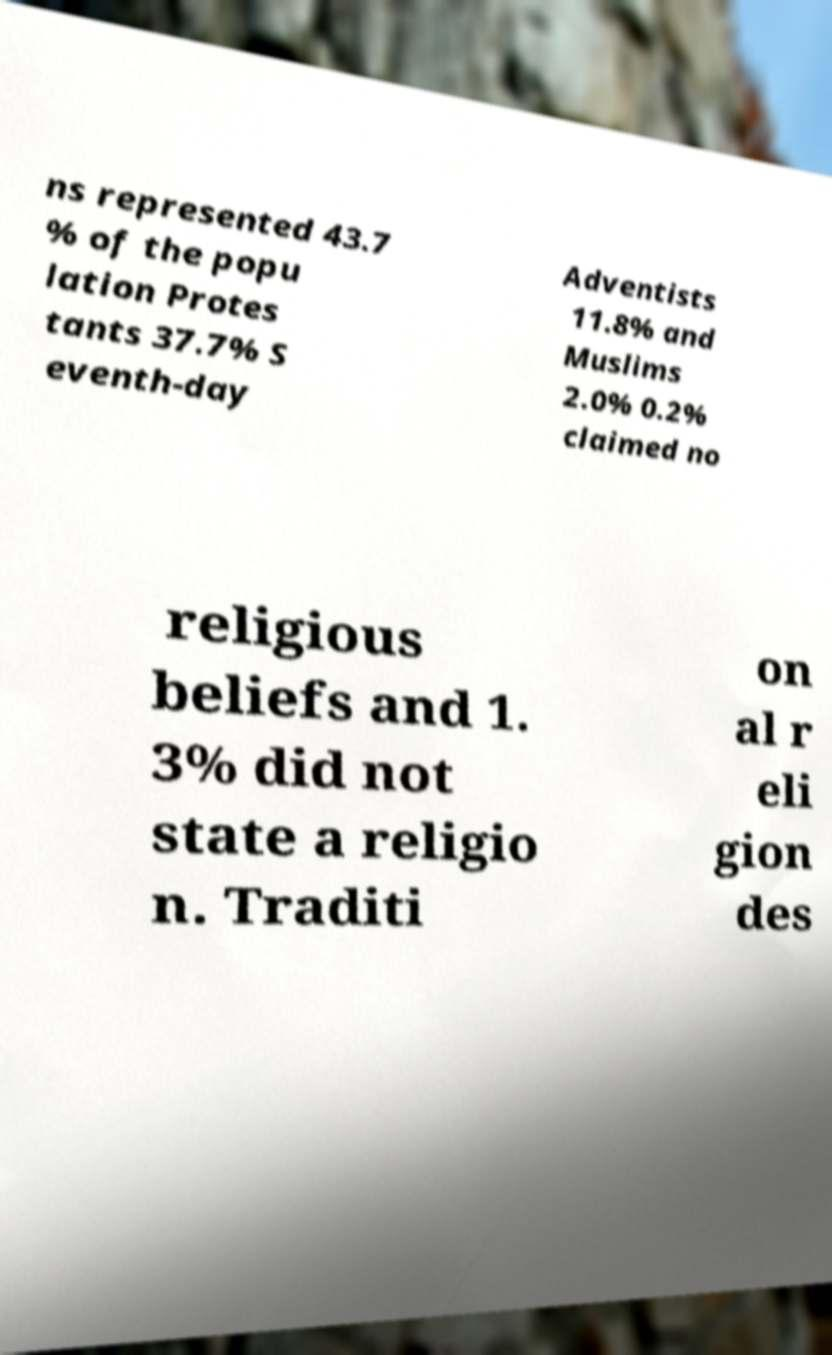Could you assist in decoding the text presented in this image and type it out clearly? ns represented 43.7 % of the popu lation Protes tants 37.7% S eventh-day Adventists 11.8% and Muslims 2.0% 0.2% claimed no religious beliefs and 1. 3% did not state a religio n. Traditi on al r eli gion des 